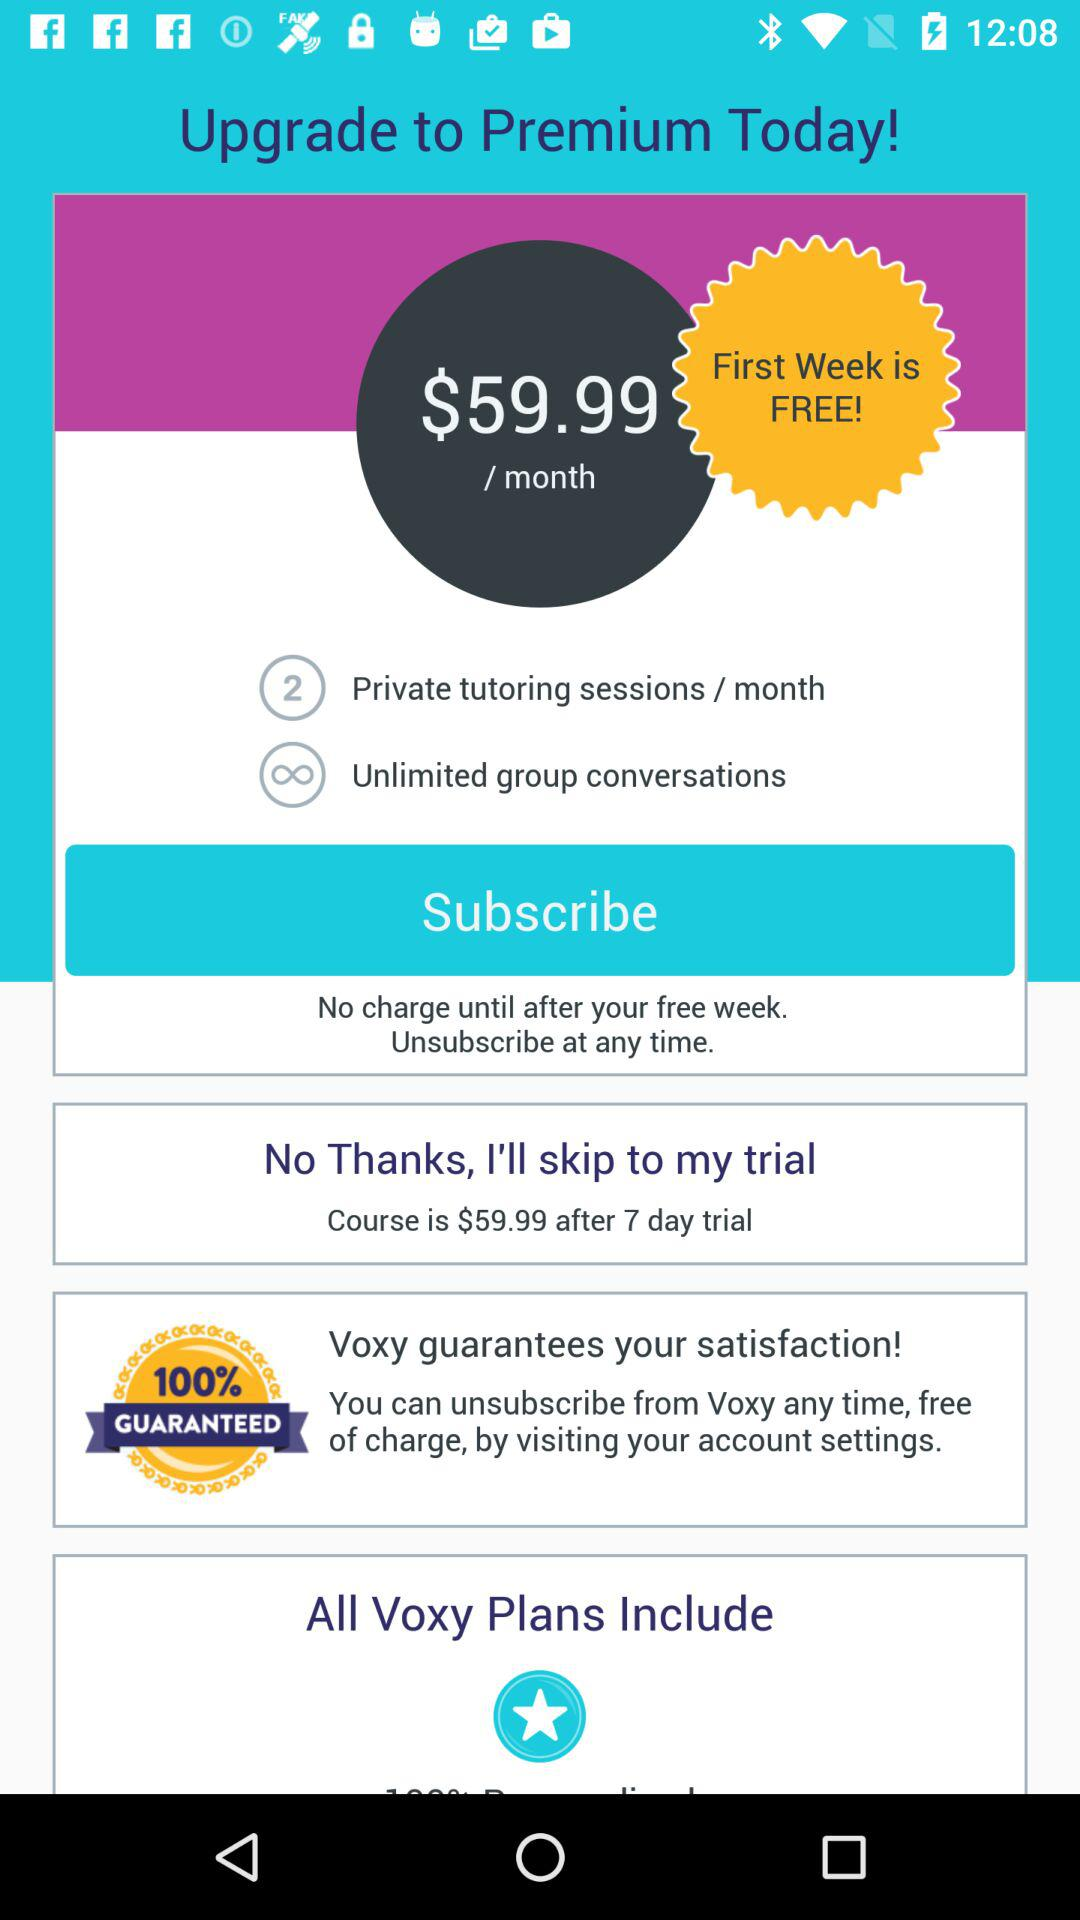How much does the premium plan cost per month? The cost of a premium plan is $59.99 per month. 